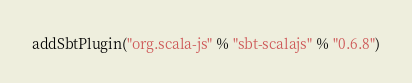Convert code to text. <code><loc_0><loc_0><loc_500><loc_500><_Scala_>addSbtPlugin("org.scala-js" % "sbt-scalajs" % "0.6.8")
</code> 